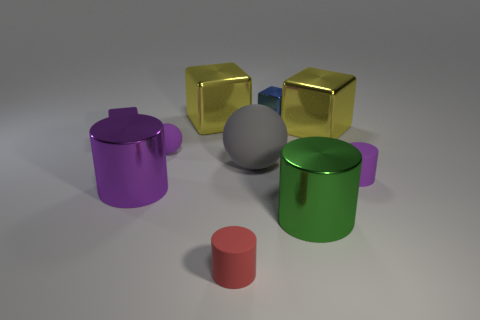Subtract all cyan cubes. Subtract all brown cylinders. How many cubes are left? 4 Subtract all spheres. How many objects are left? 8 Add 5 tiny red objects. How many tiny red objects are left? 6 Add 3 gray cubes. How many gray cubes exist? 3 Subtract 1 purple spheres. How many objects are left? 9 Subtract all big purple matte cubes. Subtract all large gray rubber things. How many objects are left? 9 